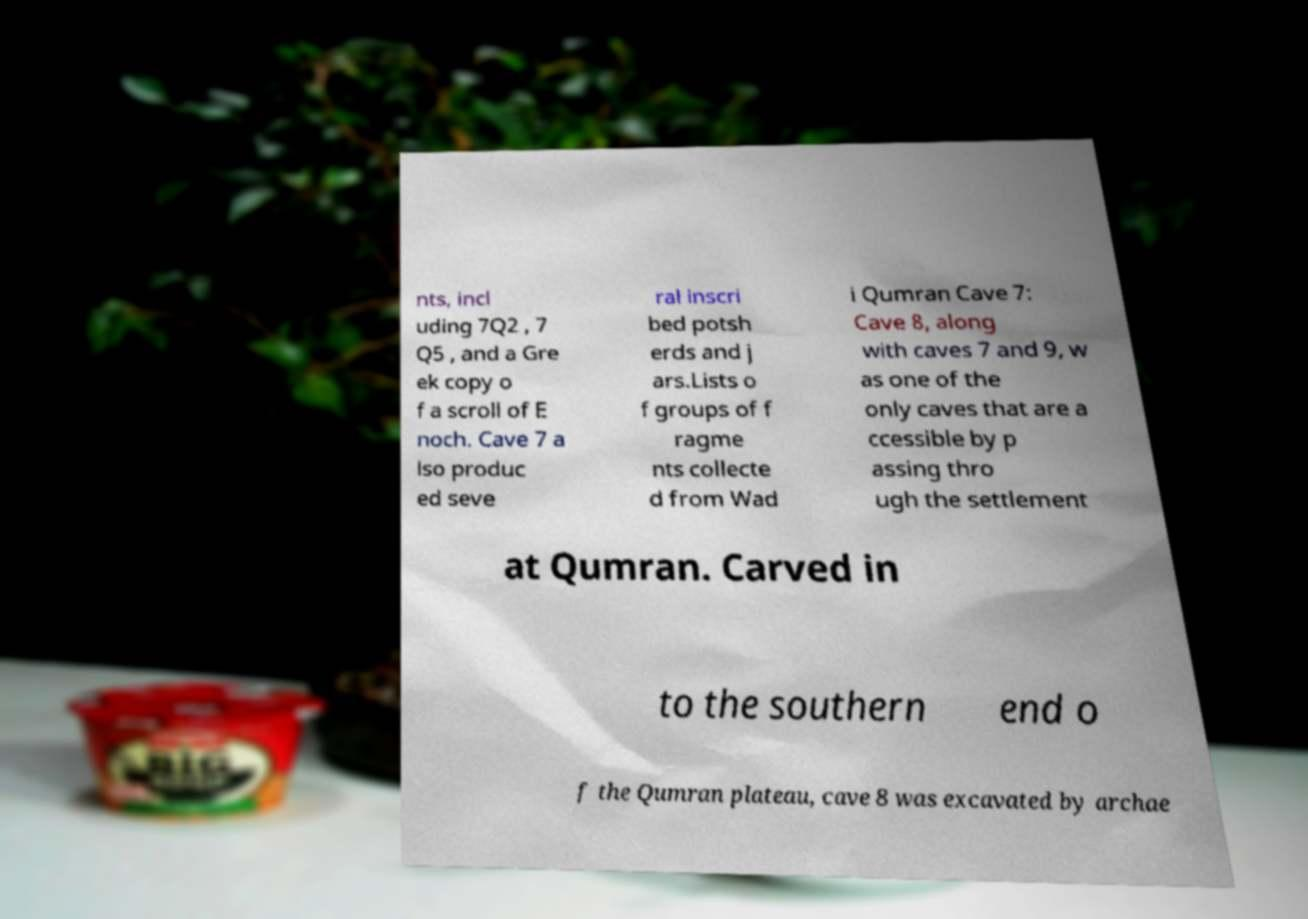Could you extract and type out the text from this image? nts, incl uding 7Q2 , 7 Q5 , and a Gre ek copy o f a scroll of E noch. Cave 7 a lso produc ed seve ral inscri bed potsh erds and j ars.Lists o f groups of f ragme nts collecte d from Wad i Qumran Cave 7: Cave 8, along with caves 7 and 9, w as one of the only caves that are a ccessible by p assing thro ugh the settlement at Qumran. Carved in to the southern end o f the Qumran plateau, cave 8 was excavated by archae 